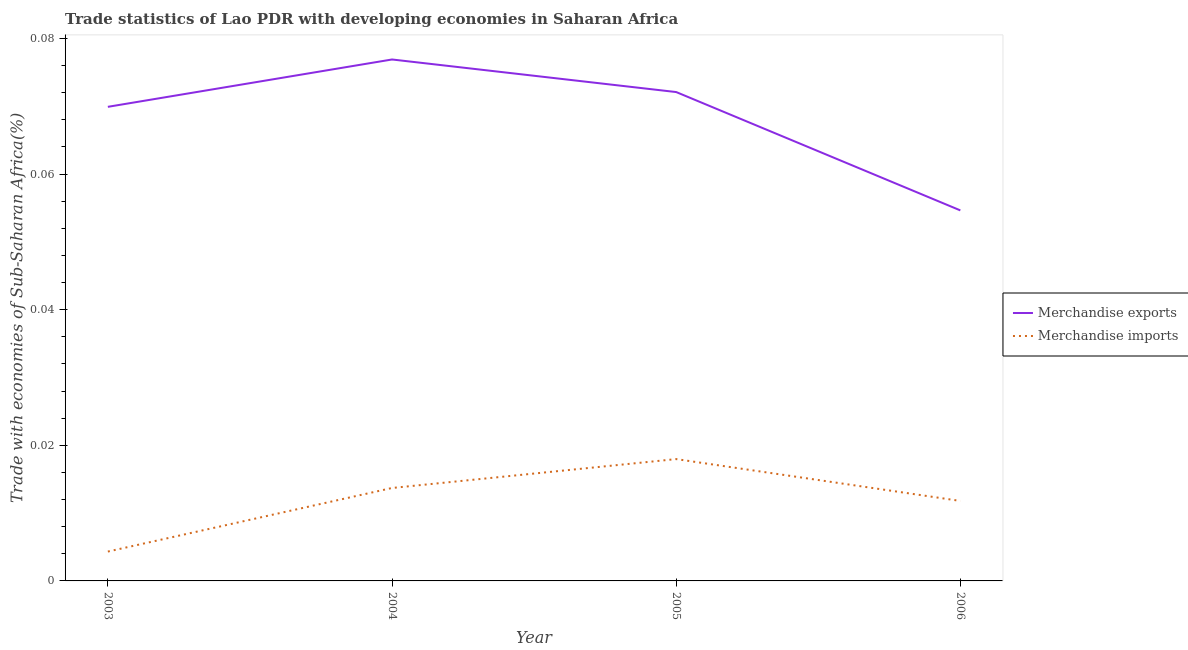Does the line corresponding to merchandise exports intersect with the line corresponding to merchandise imports?
Your answer should be compact. No. Is the number of lines equal to the number of legend labels?
Provide a succinct answer. Yes. What is the merchandise exports in 2003?
Provide a short and direct response. 0.07. Across all years, what is the maximum merchandise imports?
Ensure brevity in your answer.  0.02. Across all years, what is the minimum merchandise imports?
Ensure brevity in your answer.  0. In which year was the merchandise imports maximum?
Provide a succinct answer. 2005. In which year was the merchandise exports minimum?
Your answer should be very brief. 2006. What is the total merchandise exports in the graph?
Provide a short and direct response. 0.27. What is the difference between the merchandise exports in 2003 and that in 2005?
Your answer should be very brief. -0. What is the difference between the merchandise imports in 2003 and the merchandise exports in 2006?
Your answer should be very brief. -0.05. What is the average merchandise exports per year?
Your answer should be compact. 0.07. In the year 2006, what is the difference between the merchandise exports and merchandise imports?
Make the answer very short. 0.04. What is the ratio of the merchandise imports in 2003 to that in 2006?
Make the answer very short. 0.37. Is the merchandise exports in 2003 less than that in 2006?
Offer a terse response. No. Is the difference between the merchandise exports in 2004 and 2006 greater than the difference between the merchandise imports in 2004 and 2006?
Your response must be concise. Yes. What is the difference between the highest and the second highest merchandise imports?
Keep it short and to the point. 0. What is the difference between the highest and the lowest merchandise imports?
Provide a short and direct response. 0.01. In how many years, is the merchandise exports greater than the average merchandise exports taken over all years?
Your answer should be compact. 3. Does the merchandise exports monotonically increase over the years?
Give a very brief answer. No. How many lines are there?
Provide a succinct answer. 2. How many years are there in the graph?
Your answer should be compact. 4. Does the graph contain any zero values?
Give a very brief answer. No. What is the title of the graph?
Make the answer very short. Trade statistics of Lao PDR with developing economies in Saharan Africa. What is the label or title of the X-axis?
Keep it short and to the point. Year. What is the label or title of the Y-axis?
Offer a very short reply. Trade with economies of Sub-Saharan Africa(%). What is the Trade with economies of Sub-Saharan Africa(%) in Merchandise exports in 2003?
Keep it short and to the point. 0.07. What is the Trade with economies of Sub-Saharan Africa(%) in Merchandise imports in 2003?
Ensure brevity in your answer.  0. What is the Trade with economies of Sub-Saharan Africa(%) in Merchandise exports in 2004?
Ensure brevity in your answer.  0.08. What is the Trade with economies of Sub-Saharan Africa(%) of Merchandise imports in 2004?
Ensure brevity in your answer.  0.01. What is the Trade with economies of Sub-Saharan Africa(%) in Merchandise exports in 2005?
Ensure brevity in your answer.  0.07. What is the Trade with economies of Sub-Saharan Africa(%) of Merchandise imports in 2005?
Keep it short and to the point. 0.02. What is the Trade with economies of Sub-Saharan Africa(%) in Merchandise exports in 2006?
Provide a short and direct response. 0.05. What is the Trade with economies of Sub-Saharan Africa(%) in Merchandise imports in 2006?
Ensure brevity in your answer.  0.01. Across all years, what is the maximum Trade with economies of Sub-Saharan Africa(%) in Merchandise exports?
Make the answer very short. 0.08. Across all years, what is the maximum Trade with economies of Sub-Saharan Africa(%) in Merchandise imports?
Keep it short and to the point. 0.02. Across all years, what is the minimum Trade with economies of Sub-Saharan Africa(%) in Merchandise exports?
Ensure brevity in your answer.  0.05. Across all years, what is the minimum Trade with economies of Sub-Saharan Africa(%) in Merchandise imports?
Give a very brief answer. 0. What is the total Trade with economies of Sub-Saharan Africa(%) in Merchandise exports in the graph?
Your answer should be very brief. 0.27. What is the total Trade with economies of Sub-Saharan Africa(%) in Merchandise imports in the graph?
Your answer should be compact. 0.05. What is the difference between the Trade with economies of Sub-Saharan Africa(%) in Merchandise exports in 2003 and that in 2004?
Ensure brevity in your answer.  -0.01. What is the difference between the Trade with economies of Sub-Saharan Africa(%) in Merchandise imports in 2003 and that in 2004?
Your answer should be very brief. -0.01. What is the difference between the Trade with economies of Sub-Saharan Africa(%) in Merchandise exports in 2003 and that in 2005?
Your answer should be compact. -0. What is the difference between the Trade with economies of Sub-Saharan Africa(%) of Merchandise imports in 2003 and that in 2005?
Ensure brevity in your answer.  -0.01. What is the difference between the Trade with economies of Sub-Saharan Africa(%) in Merchandise exports in 2003 and that in 2006?
Your answer should be very brief. 0.02. What is the difference between the Trade with economies of Sub-Saharan Africa(%) of Merchandise imports in 2003 and that in 2006?
Offer a terse response. -0.01. What is the difference between the Trade with economies of Sub-Saharan Africa(%) in Merchandise exports in 2004 and that in 2005?
Provide a short and direct response. 0. What is the difference between the Trade with economies of Sub-Saharan Africa(%) in Merchandise imports in 2004 and that in 2005?
Offer a terse response. -0. What is the difference between the Trade with economies of Sub-Saharan Africa(%) of Merchandise exports in 2004 and that in 2006?
Offer a terse response. 0.02. What is the difference between the Trade with economies of Sub-Saharan Africa(%) of Merchandise imports in 2004 and that in 2006?
Offer a terse response. 0. What is the difference between the Trade with economies of Sub-Saharan Africa(%) in Merchandise exports in 2005 and that in 2006?
Make the answer very short. 0.02. What is the difference between the Trade with economies of Sub-Saharan Africa(%) in Merchandise imports in 2005 and that in 2006?
Provide a short and direct response. 0.01. What is the difference between the Trade with economies of Sub-Saharan Africa(%) of Merchandise exports in 2003 and the Trade with economies of Sub-Saharan Africa(%) of Merchandise imports in 2004?
Keep it short and to the point. 0.06. What is the difference between the Trade with economies of Sub-Saharan Africa(%) in Merchandise exports in 2003 and the Trade with economies of Sub-Saharan Africa(%) in Merchandise imports in 2005?
Provide a short and direct response. 0.05. What is the difference between the Trade with economies of Sub-Saharan Africa(%) in Merchandise exports in 2003 and the Trade with economies of Sub-Saharan Africa(%) in Merchandise imports in 2006?
Make the answer very short. 0.06. What is the difference between the Trade with economies of Sub-Saharan Africa(%) of Merchandise exports in 2004 and the Trade with economies of Sub-Saharan Africa(%) of Merchandise imports in 2005?
Provide a succinct answer. 0.06. What is the difference between the Trade with economies of Sub-Saharan Africa(%) of Merchandise exports in 2004 and the Trade with economies of Sub-Saharan Africa(%) of Merchandise imports in 2006?
Provide a succinct answer. 0.07. What is the difference between the Trade with economies of Sub-Saharan Africa(%) of Merchandise exports in 2005 and the Trade with economies of Sub-Saharan Africa(%) of Merchandise imports in 2006?
Offer a very short reply. 0.06. What is the average Trade with economies of Sub-Saharan Africa(%) in Merchandise exports per year?
Offer a terse response. 0.07. What is the average Trade with economies of Sub-Saharan Africa(%) of Merchandise imports per year?
Provide a succinct answer. 0.01. In the year 2003, what is the difference between the Trade with economies of Sub-Saharan Africa(%) of Merchandise exports and Trade with economies of Sub-Saharan Africa(%) of Merchandise imports?
Your response must be concise. 0.07. In the year 2004, what is the difference between the Trade with economies of Sub-Saharan Africa(%) of Merchandise exports and Trade with economies of Sub-Saharan Africa(%) of Merchandise imports?
Ensure brevity in your answer.  0.06. In the year 2005, what is the difference between the Trade with economies of Sub-Saharan Africa(%) in Merchandise exports and Trade with economies of Sub-Saharan Africa(%) in Merchandise imports?
Provide a succinct answer. 0.05. In the year 2006, what is the difference between the Trade with economies of Sub-Saharan Africa(%) of Merchandise exports and Trade with economies of Sub-Saharan Africa(%) of Merchandise imports?
Your answer should be compact. 0.04. What is the ratio of the Trade with economies of Sub-Saharan Africa(%) in Merchandise exports in 2003 to that in 2004?
Make the answer very short. 0.91. What is the ratio of the Trade with economies of Sub-Saharan Africa(%) of Merchandise imports in 2003 to that in 2004?
Provide a short and direct response. 0.32. What is the ratio of the Trade with economies of Sub-Saharan Africa(%) of Merchandise exports in 2003 to that in 2005?
Your answer should be very brief. 0.97. What is the ratio of the Trade with economies of Sub-Saharan Africa(%) in Merchandise imports in 2003 to that in 2005?
Offer a very short reply. 0.24. What is the ratio of the Trade with economies of Sub-Saharan Africa(%) of Merchandise exports in 2003 to that in 2006?
Your answer should be compact. 1.28. What is the ratio of the Trade with economies of Sub-Saharan Africa(%) of Merchandise imports in 2003 to that in 2006?
Offer a terse response. 0.37. What is the ratio of the Trade with economies of Sub-Saharan Africa(%) in Merchandise exports in 2004 to that in 2005?
Your answer should be compact. 1.07. What is the ratio of the Trade with economies of Sub-Saharan Africa(%) of Merchandise imports in 2004 to that in 2005?
Ensure brevity in your answer.  0.76. What is the ratio of the Trade with economies of Sub-Saharan Africa(%) of Merchandise exports in 2004 to that in 2006?
Make the answer very short. 1.41. What is the ratio of the Trade with economies of Sub-Saharan Africa(%) of Merchandise imports in 2004 to that in 2006?
Ensure brevity in your answer.  1.16. What is the ratio of the Trade with economies of Sub-Saharan Africa(%) in Merchandise exports in 2005 to that in 2006?
Offer a terse response. 1.32. What is the ratio of the Trade with economies of Sub-Saharan Africa(%) in Merchandise imports in 2005 to that in 2006?
Offer a very short reply. 1.52. What is the difference between the highest and the second highest Trade with economies of Sub-Saharan Africa(%) of Merchandise exports?
Keep it short and to the point. 0. What is the difference between the highest and the second highest Trade with economies of Sub-Saharan Africa(%) of Merchandise imports?
Offer a very short reply. 0. What is the difference between the highest and the lowest Trade with economies of Sub-Saharan Africa(%) in Merchandise exports?
Offer a terse response. 0.02. What is the difference between the highest and the lowest Trade with economies of Sub-Saharan Africa(%) of Merchandise imports?
Offer a very short reply. 0.01. 